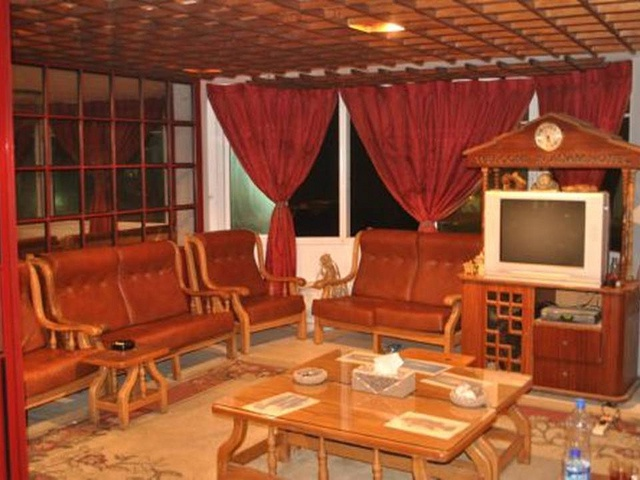Describe the objects in this image and their specific colors. I can see dining table in brown, tan, and red tones, couch in brown, maroon, and red tones, tv in brown, tan, and gray tones, couch in brown, maroon, and red tones, and chair in brown, maroon, and salmon tones in this image. 